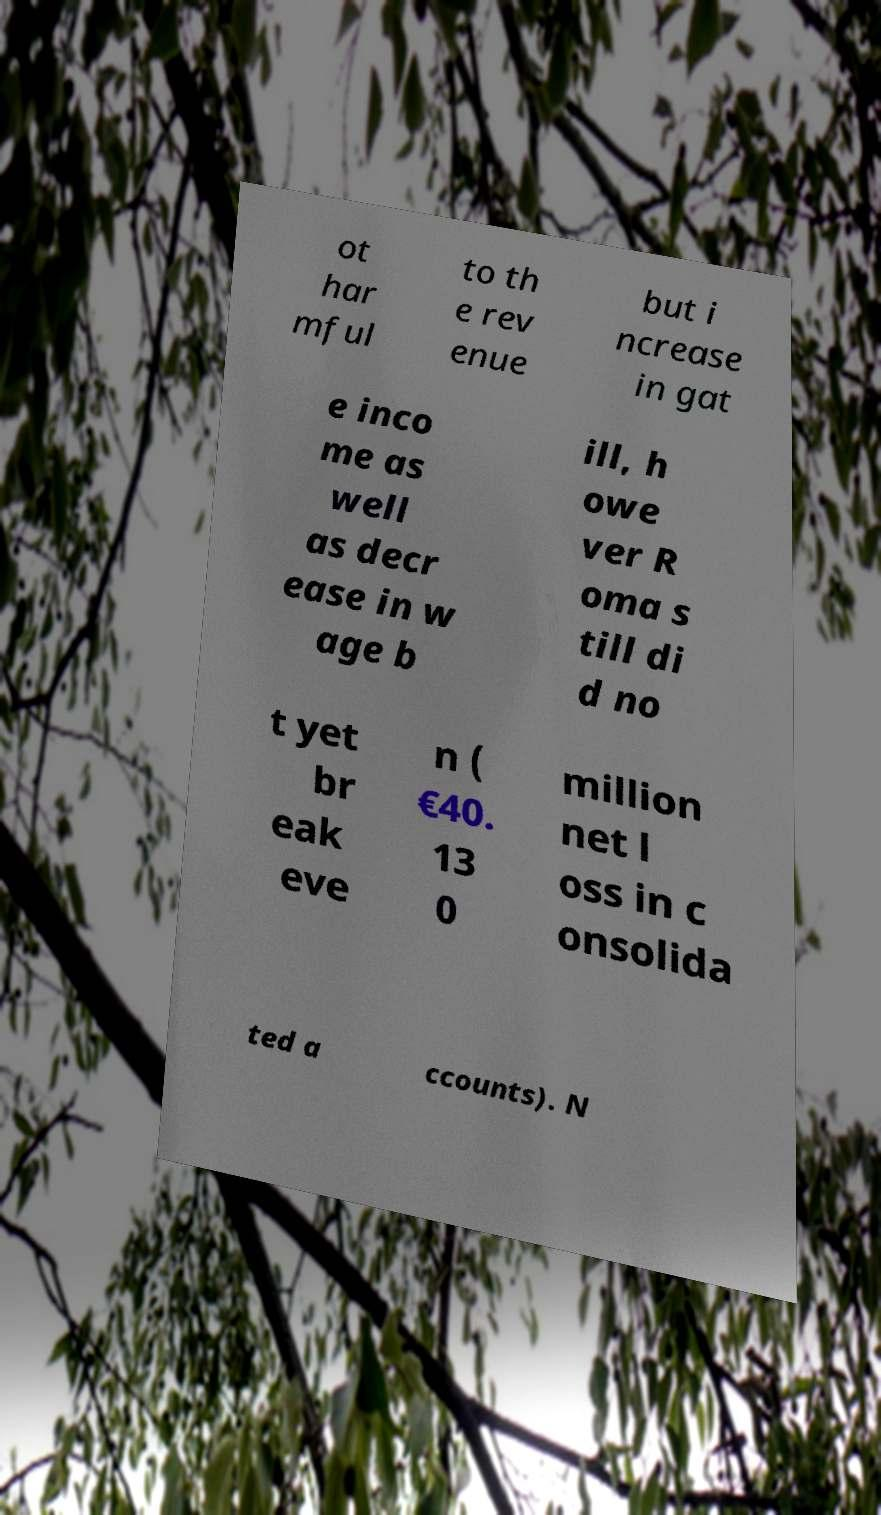Can you read and provide the text displayed in the image?This photo seems to have some interesting text. Can you extract and type it out for me? ot har mful to th e rev enue but i ncrease in gat e inco me as well as decr ease in w age b ill, h owe ver R oma s till di d no t yet br eak eve n ( €40. 13 0 million net l oss in c onsolida ted a ccounts). N 